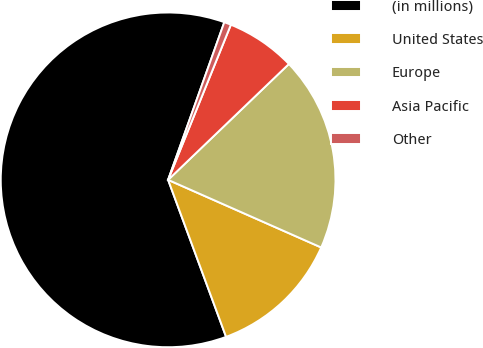Convert chart. <chart><loc_0><loc_0><loc_500><loc_500><pie_chart><fcel>(in millions)<fcel>United States<fcel>Europe<fcel>Asia Pacific<fcel>Other<nl><fcel>61.08%<fcel>12.75%<fcel>18.79%<fcel>6.71%<fcel>0.67%<nl></chart> 